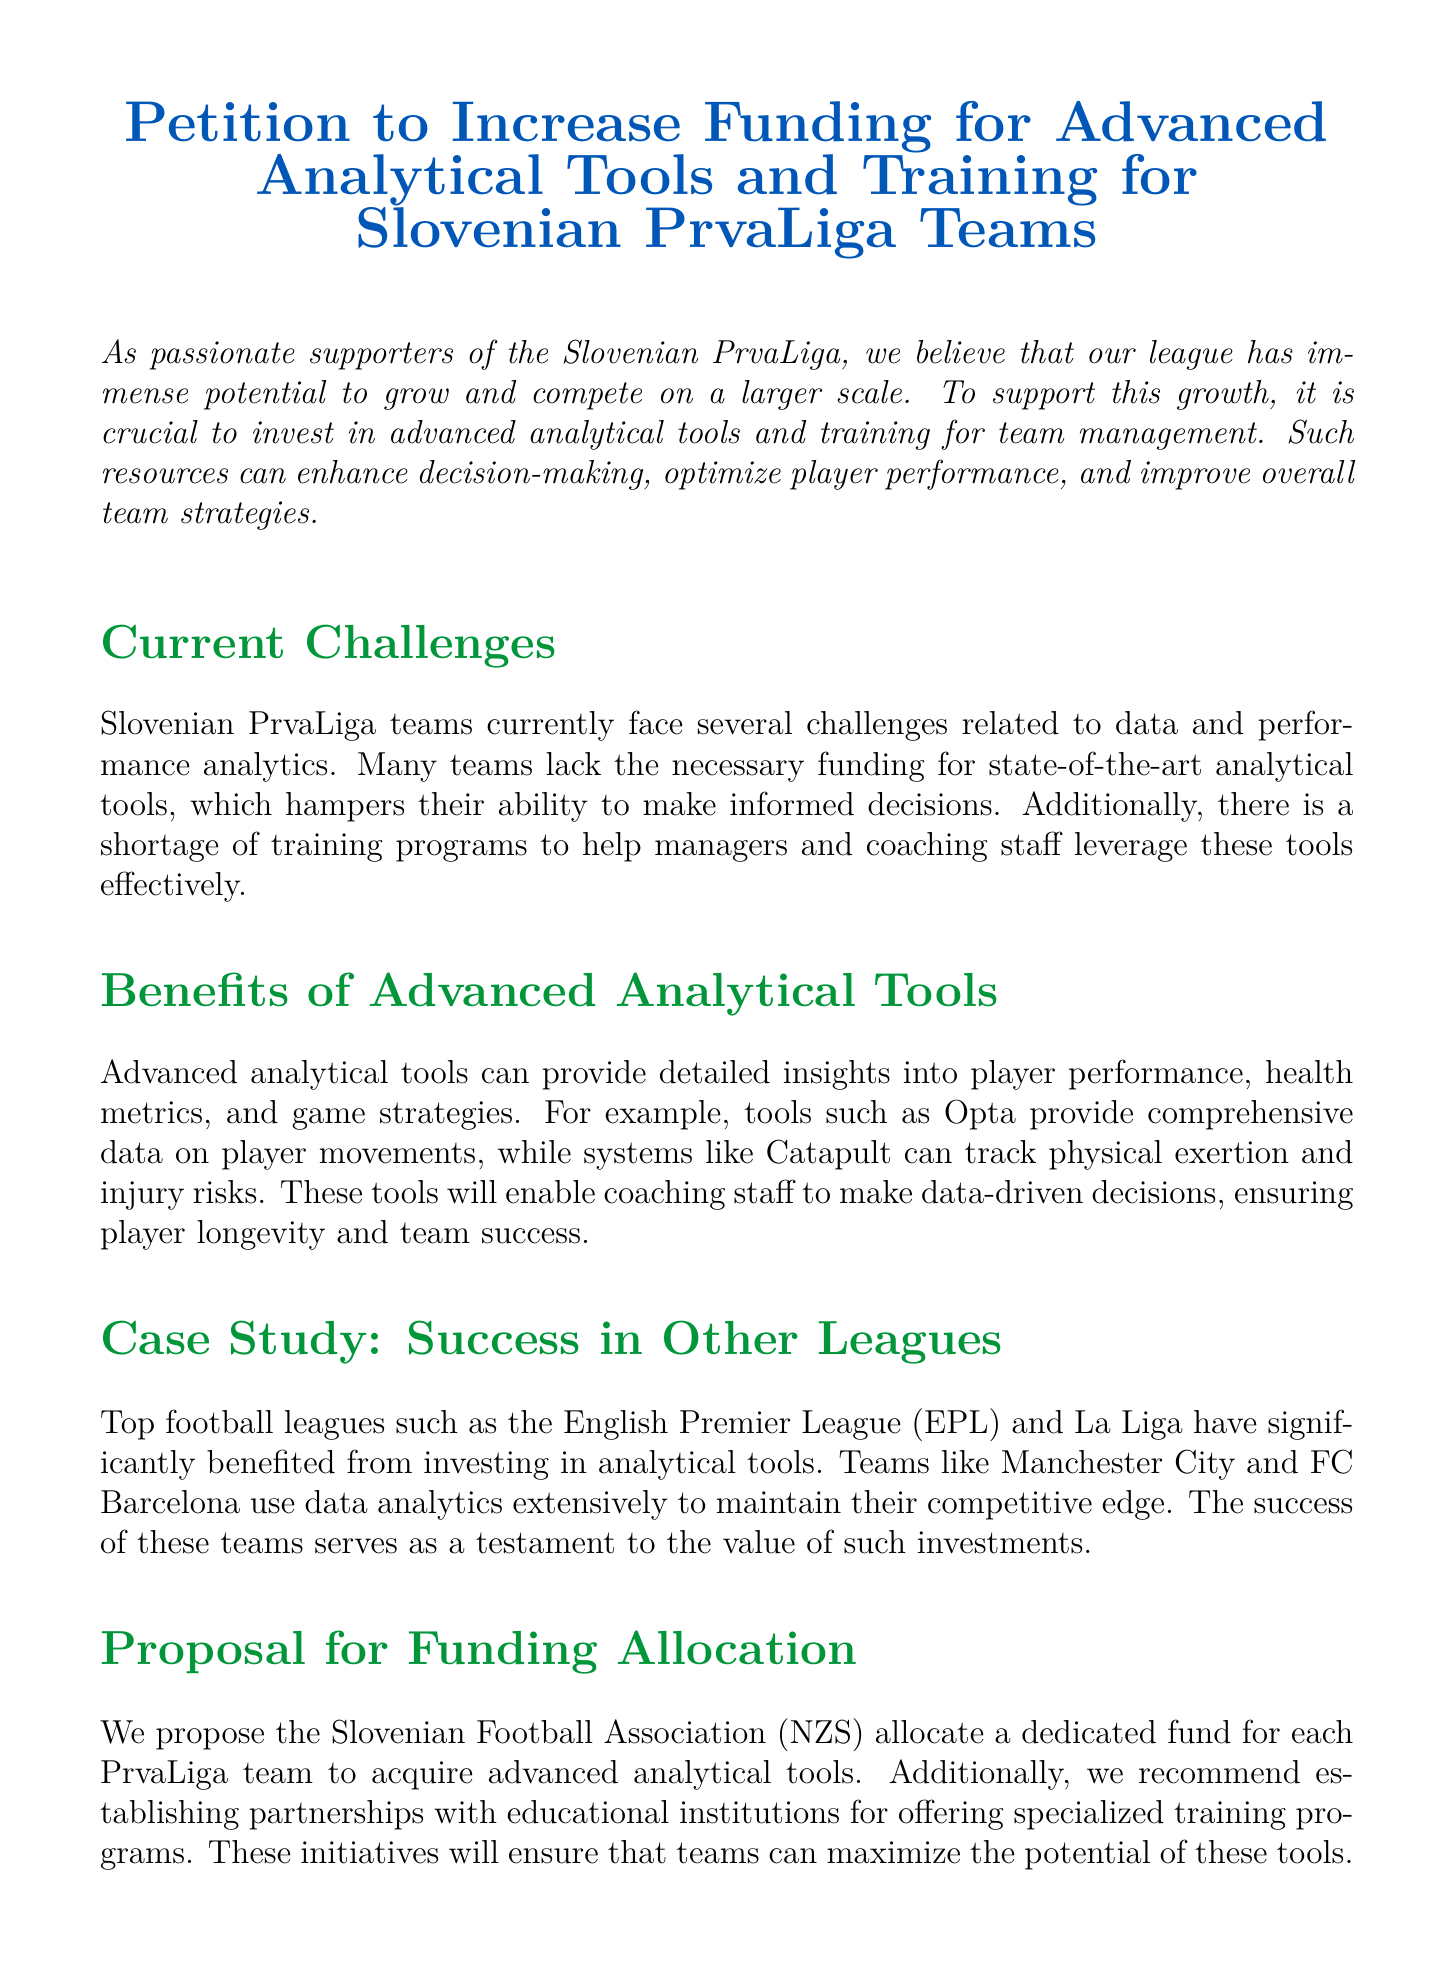What is the title of the petition? The title of the petition is stated at the beginning of the document, which is "Petition to Increase Funding for Advanced Analytical Tools and Training for Slovenian PrvaLiga Teams."
Answer: Petition to Increase Funding for Advanced Analytical Tools and Training for Slovenian PrvaLiga Teams What organization is being petitioned? The document calls upon the "Slovenian Football Association" for support and action, which is mentioned in the call to action section.
Answer: Slovenian Football Association What is highlighted as a current challenge for Slovenian PrvaLiga teams? The document mentions a lack of funding for state-of-the-art analytical tools as a current challenge faced by teams in the league.
Answer: Lack of funding for analytical tools Which case study is mentioned to illustrate success in other leagues? The document references teams in the English Premier League and La Liga as examples, particularly mentioning Manchester City and FC Barcelona.
Answer: Manchester City and FC Barcelona What is proposed to enhance team management in the document? The petition proposes allocating a dedicated fund for PrvaLiga teams to acquire advanced analytical tools and establishing partnerships for training programs.
Answer: Dedicated fund and training programs What is the color used for section titles in the document? The document uses a specific shade of green identified as "sloveniagreen" for all section titles, as part of its formatting.
Answer: sloveniagreen What benefit does the document claim advanced analytical tools provide? The document states that advanced analytical tools can provide detailed insights into player performance, health metrics, and game strategies, enhancing decision-making.
Answer: Detailed insights into player performance What kind of data does the document specifically mention using tools like Opta and Catapult? The petition outlines that tools like Opta provide comprehensive data on player movements, while Catapult tracks physical exertion and injury risks.
Answer: Player movements and physical exertion tracking What is the call to action in the petition? The call to action urges stakeholders to support funding increases for the advanced analytical tools and training, aimed at improving Slovenian football.
Answer: Increase funding for advanced analytical tools and training 